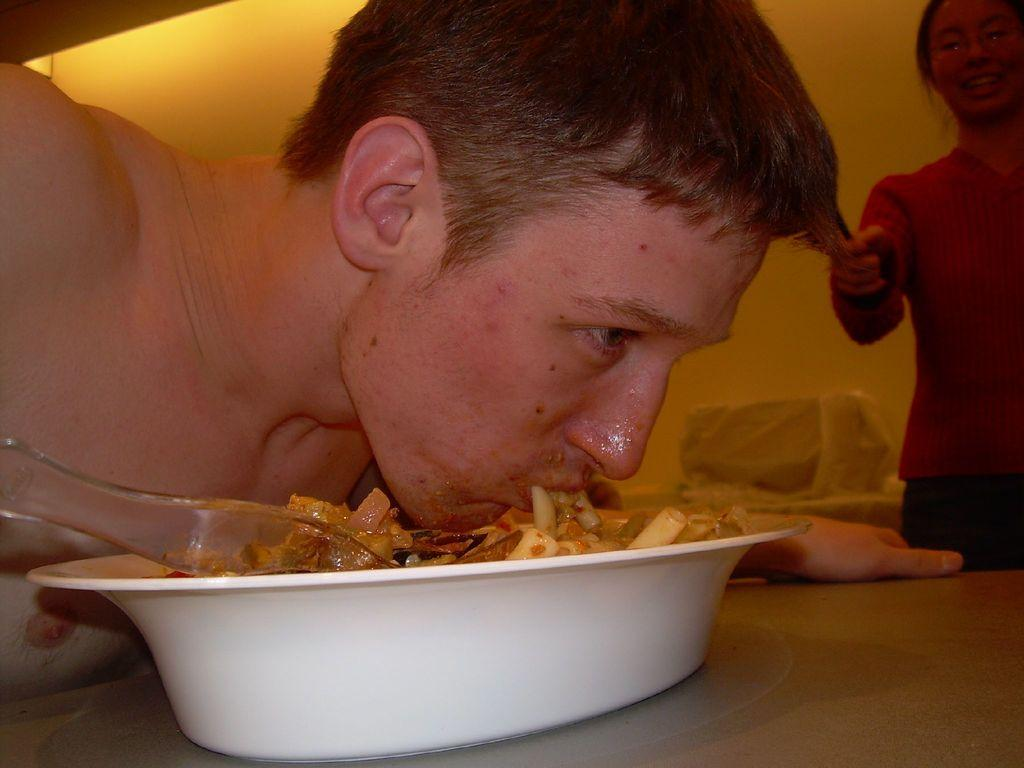Who is present in the image? There is a person in the image. What is the person doing in the image? The person is bending towards a bowl. Where is the bowl located in the image? The bowl is on a table. What is in the bowl? The bowl contains some food content. What type of wire is being used for the protest in the image? There is no wire or protest present in the image. 